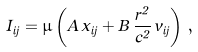Convert formula to latex. <formula><loc_0><loc_0><loc_500><loc_500>I _ { i j } = \mu \left ( A \, { \hat { x } } _ { i j } + B \, \frac { r ^ { 2 } } { c ^ { 2 } } \, { \hat { v } } _ { i j } \right ) \, ,</formula> 